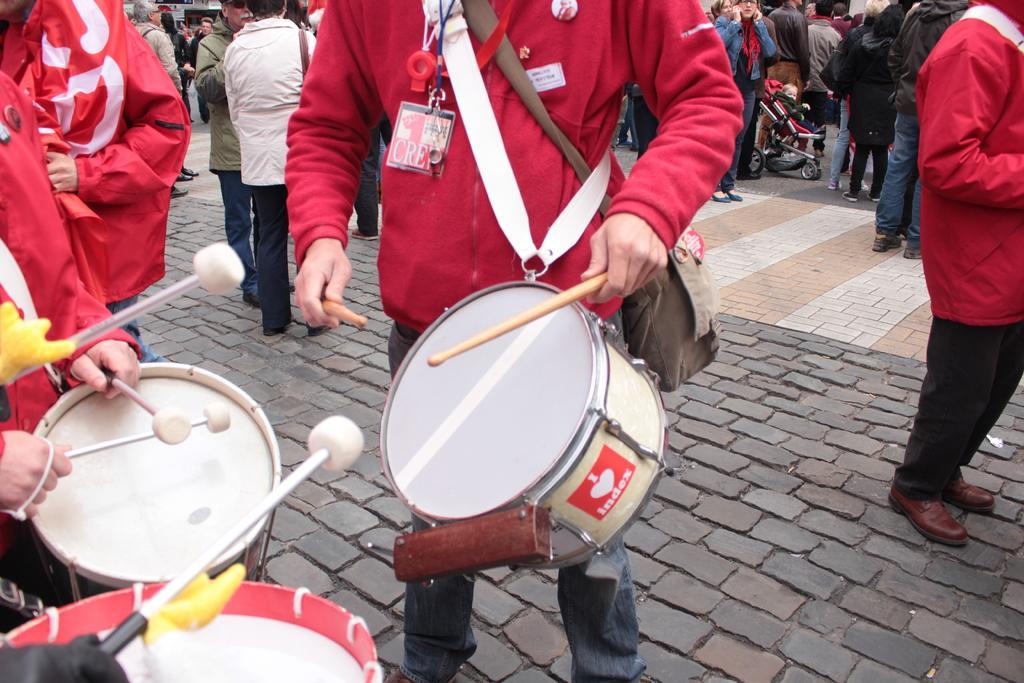Describe this image in one or two sentences. There is a group of persons standing on the left side is playing drums, and there are some persons standing in the background. 